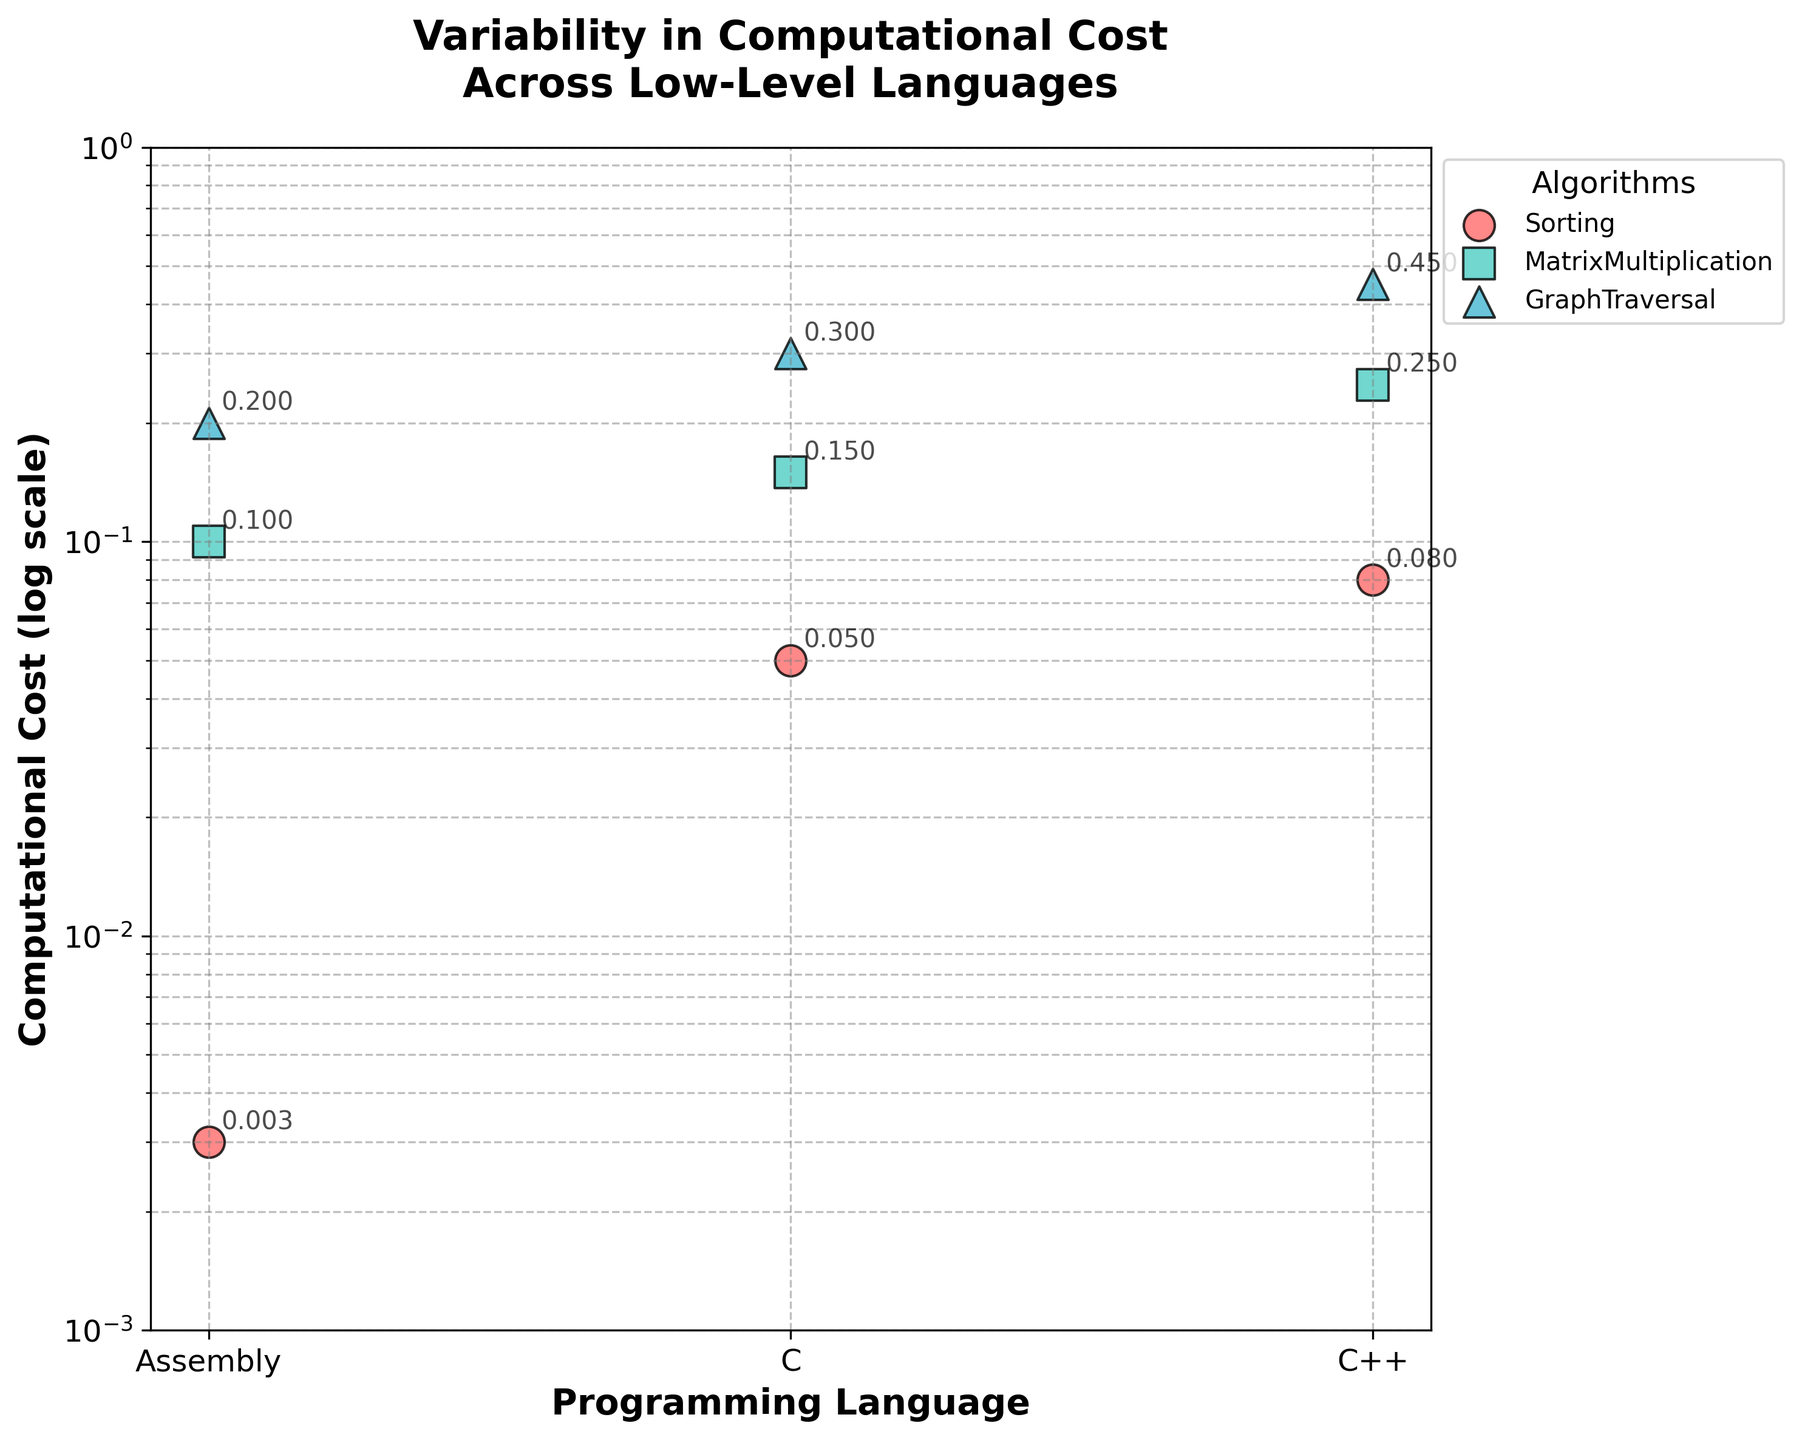What is the title of the scatter plot? The title is easily seen at the top of the plot. It reads "Variability in Computational Cost\nAcross Low-Level Languages".
Answer: Variability in Computational Cost Across Low-Level Languages What are the labels on the x-axis and y-axis of the scatter plot? The x-axis label is "Programming Language", and the y-axis label is "Computational Cost (log scale)".
Answer: Programming Language, Computational Cost (log scale) Which algorithm has the lowest computational cost in Assembly language? The lowest computational cost for Assembly language is for the "Sorting" algorithm, which is 0.003. This can be seen from the dot representing the lowest position on the y-axis for Assembly language.
Answer: Sorting What is the computational cost difference between Sorting in C++ and GraphTraversal in Assembly? The computational cost of Sorting in C++ is 0.08, and the computational cost of GraphTraversal in Assembly is 0.20. The difference is calculated as 0.20 - 0.08 = 0.12.
Answer: 0.12 How does the computational cost of MatrixMultiplication in C compare to Sorting in C++? The computational cost of MatrixMultiplication in C is 0.15, while Sorting in C++ is 0.08. 0.15 is greater than 0.08, so MatrixMultiplication in C has a higher computational cost.
Answer: Higher What is the average computational cost for the Sorting algorithm across all languages? The computational costs for Sorting are 0.003 (Assembly), 0.05 (C), and 0.08 (C++). The average is calculated as (0.003 + 0.05 + 0.08) / 3 = 0.0443.
Answer: 0.0443 Which language shows the highest computational cost for GraphTraversal? The computational costs of GraphTraversal are 0.20 (Assembly), 0.3 (C), and 0.45 (C++). The highest cost is 0.45 for C++.
Answer: C++ What is the median computational cost of the MatrixMultiplication algorithm? The computational costs are 0.1 (Assembly), 0.15 (C), and 0.25 (C++). The median value, or the middle value of a sorted list, is 0.15.
Answer: 0.15 By how much does the computational cost of GraphTraversal in C++ exceed that in Assembly? The computational cost for GraphTraversal in Assembly is 0.20, and in C++ it is 0.45. The difference is calculated as 0.45 - 0.20 = 0.25.
Answer: 0.25 